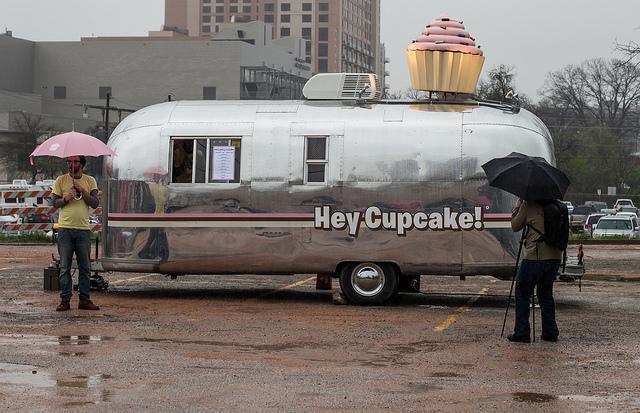How many people are in the picture?
Give a very brief answer. 2. How many oranges can be seen in the bottom box?
Give a very brief answer. 0. 